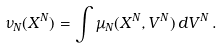Convert formula to latex. <formula><loc_0><loc_0><loc_500><loc_500>\nu _ { N } ( X ^ { N } ) = \int \mu _ { N } ( X ^ { N } , V ^ { N } ) \, d V ^ { N } \, .</formula> 